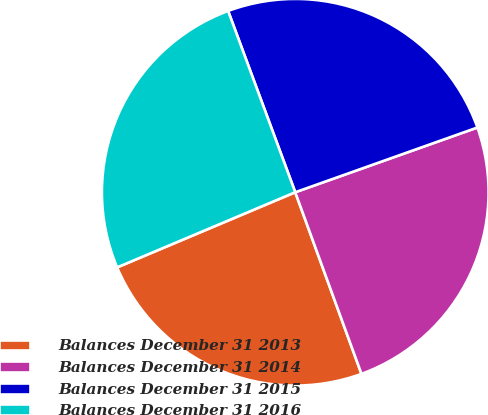<chart> <loc_0><loc_0><loc_500><loc_500><pie_chart><fcel>Balances December 31 2013<fcel>Balances December 31 2014<fcel>Balances December 31 2015<fcel>Balances December 31 2016<nl><fcel>24.21%<fcel>24.87%<fcel>25.21%<fcel>25.71%<nl></chart> 